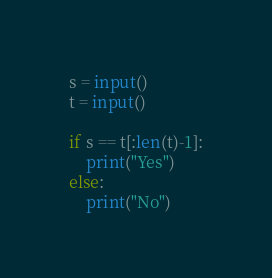Convert code to text. <code><loc_0><loc_0><loc_500><loc_500><_Python_>
s = input()
t = input()

if s == t[:len(t)-1]:
    print("Yes")
else:
    print("No")
</code> 